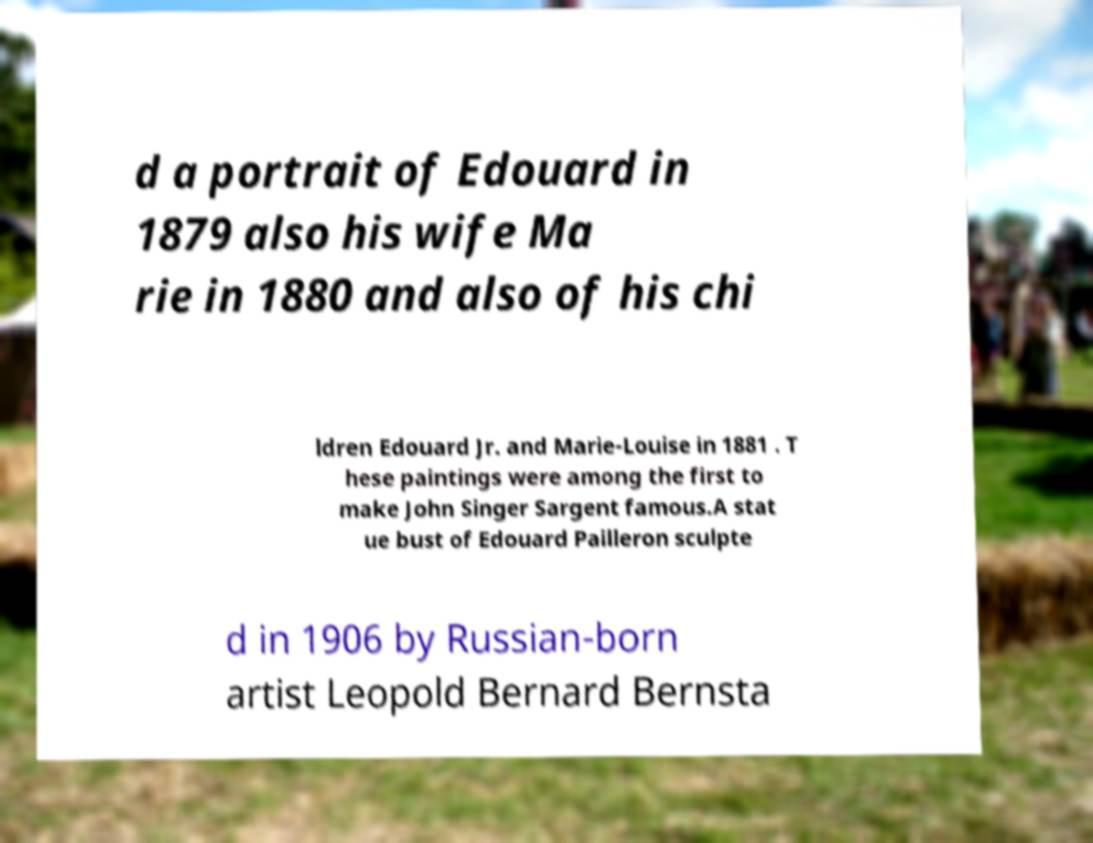Please read and relay the text visible in this image. What does it say? d a portrait of Edouard in 1879 also his wife Ma rie in 1880 and also of his chi ldren Edouard Jr. and Marie-Louise in 1881 . T hese paintings were among the first to make John Singer Sargent famous.A stat ue bust of Edouard Pailleron sculpte d in 1906 by Russian-born artist Leopold Bernard Bernsta 